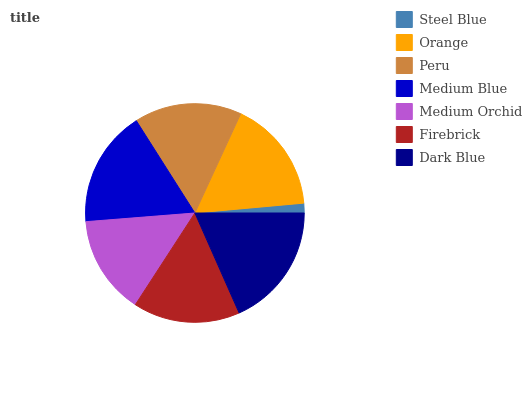Is Steel Blue the minimum?
Answer yes or no. Yes. Is Dark Blue the maximum?
Answer yes or no. Yes. Is Orange the minimum?
Answer yes or no. No. Is Orange the maximum?
Answer yes or no. No. Is Orange greater than Steel Blue?
Answer yes or no. Yes. Is Steel Blue less than Orange?
Answer yes or no. Yes. Is Steel Blue greater than Orange?
Answer yes or no. No. Is Orange less than Steel Blue?
Answer yes or no. No. Is Peru the high median?
Answer yes or no. Yes. Is Peru the low median?
Answer yes or no. Yes. Is Firebrick the high median?
Answer yes or no. No. Is Steel Blue the low median?
Answer yes or no. No. 